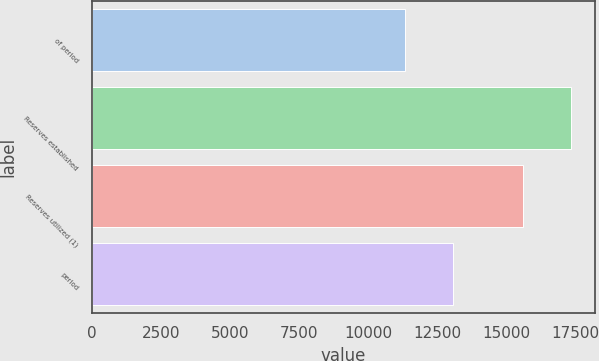<chart> <loc_0><loc_0><loc_500><loc_500><bar_chart><fcel>of period<fcel>Reserves established<fcel>Reserves utilized (1)<fcel>period<nl><fcel>11352<fcel>17352<fcel>15635<fcel>13069<nl></chart> 